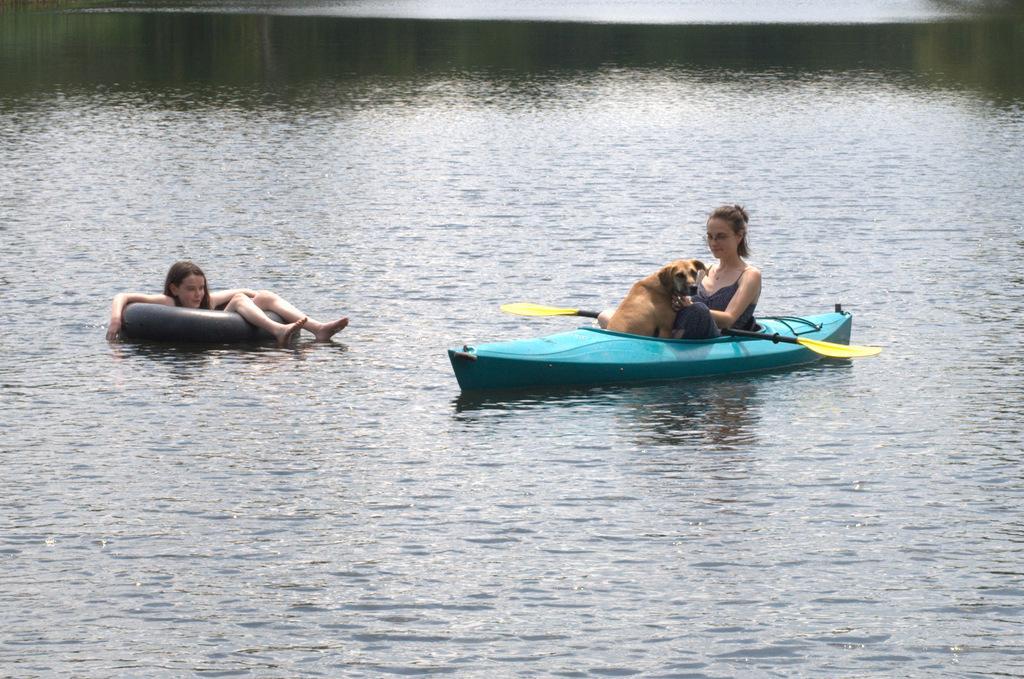Can you describe this image briefly? In this image there is water and we can see a boat. There is a lady and a dog in the boat. On the left we can see a girl sitting on the swimming ring. 